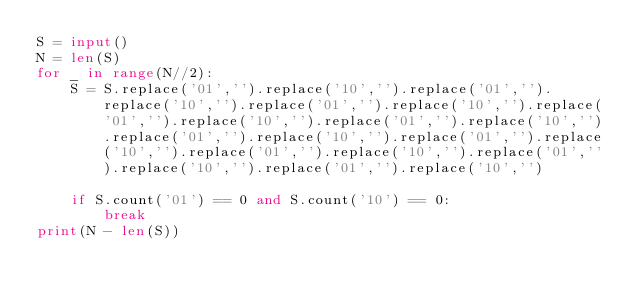Convert code to text. <code><loc_0><loc_0><loc_500><loc_500><_Python_>S = input()
N = len(S)
for _ in range(N//2):
    S = S.replace('01','').replace('10','').replace('01','').replace('10','').replace('01','').replace('10','').replace('01','').replace('10','').replace('01','').replace('10','').replace('01','').replace('10','').replace('01','').replace('10','').replace('01','').replace('10','').replace('01','').replace('10','').replace('01','').replace('10','')

    if S.count('01') == 0 and S.count('10') == 0:
        break
print(N - len(S))</code> 